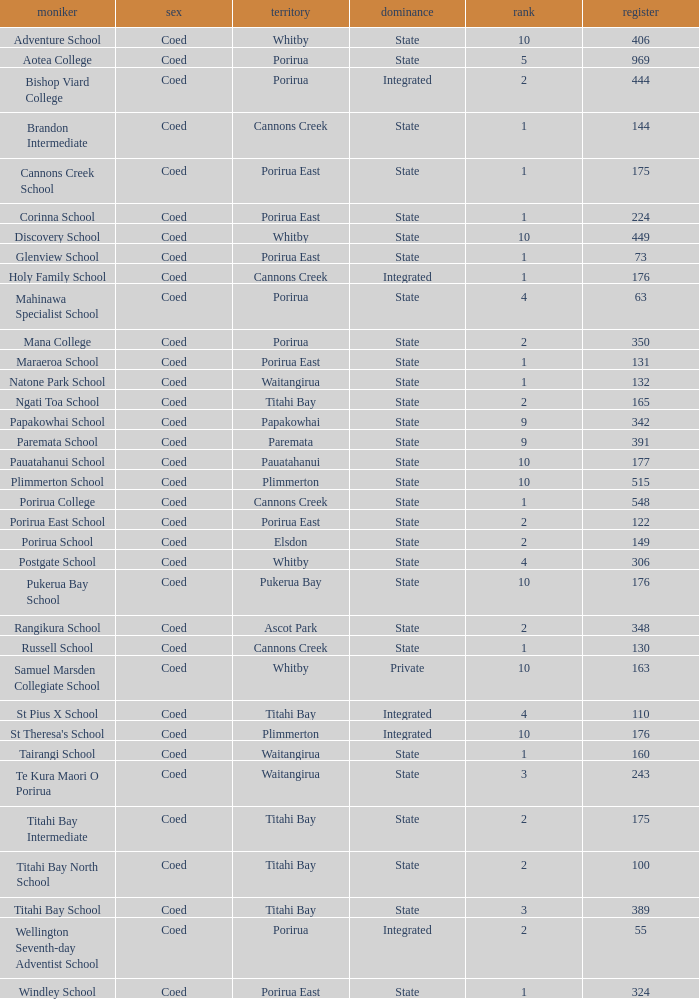What integrated school had a decile of 2 and a roll larger than 55? Bishop Viard College. Could you parse the entire table? {'header': ['moniker', 'sex', 'territory', 'dominance', 'rank', 'register'], 'rows': [['Adventure School', 'Coed', 'Whitby', 'State', '10', '406'], ['Aotea College', 'Coed', 'Porirua', 'State', '5', '969'], ['Bishop Viard College', 'Coed', 'Porirua', 'Integrated', '2', '444'], ['Brandon Intermediate', 'Coed', 'Cannons Creek', 'State', '1', '144'], ['Cannons Creek School', 'Coed', 'Porirua East', 'State', '1', '175'], ['Corinna School', 'Coed', 'Porirua East', 'State', '1', '224'], ['Discovery School', 'Coed', 'Whitby', 'State', '10', '449'], ['Glenview School', 'Coed', 'Porirua East', 'State', '1', '73'], ['Holy Family School', 'Coed', 'Cannons Creek', 'Integrated', '1', '176'], ['Mahinawa Specialist School', 'Coed', 'Porirua', 'State', '4', '63'], ['Mana College', 'Coed', 'Porirua', 'State', '2', '350'], ['Maraeroa School', 'Coed', 'Porirua East', 'State', '1', '131'], ['Natone Park School', 'Coed', 'Waitangirua', 'State', '1', '132'], ['Ngati Toa School', 'Coed', 'Titahi Bay', 'State', '2', '165'], ['Papakowhai School', 'Coed', 'Papakowhai', 'State', '9', '342'], ['Paremata School', 'Coed', 'Paremata', 'State', '9', '391'], ['Pauatahanui School', 'Coed', 'Pauatahanui', 'State', '10', '177'], ['Plimmerton School', 'Coed', 'Plimmerton', 'State', '10', '515'], ['Porirua College', 'Coed', 'Cannons Creek', 'State', '1', '548'], ['Porirua East School', 'Coed', 'Porirua East', 'State', '2', '122'], ['Porirua School', 'Coed', 'Elsdon', 'State', '2', '149'], ['Postgate School', 'Coed', 'Whitby', 'State', '4', '306'], ['Pukerua Bay School', 'Coed', 'Pukerua Bay', 'State', '10', '176'], ['Rangikura School', 'Coed', 'Ascot Park', 'State', '2', '348'], ['Russell School', 'Coed', 'Cannons Creek', 'State', '1', '130'], ['Samuel Marsden Collegiate School', 'Coed', 'Whitby', 'Private', '10', '163'], ['St Pius X School', 'Coed', 'Titahi Bay', 'Integrated', '4', '110'], ["St Theresa's School", 'Coed', 'Plimmerton', 'Integrated', '10', '176'], ['Tairangi School', 'Coed', 'Waitangirua', 'State', '1', '160'], ['Te Kura Maori O Porirua', 'Coed', 'Waitangirua', 'State', '3', '243'], ['Titahi Bay Intermediate', 'Coed', 'Titahi Bay', 'State', '2', '175'], ['Titahi Bay North School', 'Coed', 'Titahi Bay', 'State', '2', '100'], ['Titahi Bay School', 'Coed', 'Titahi Bay', 'State', '3', '389'], ['Wellington Seventh-day Adventist School', 'Coed', 'Porirua', 'Integrated', '2', '55'], ['Windley School', 'Coed', 'Porirua East', 'State', '1', '324']]} 